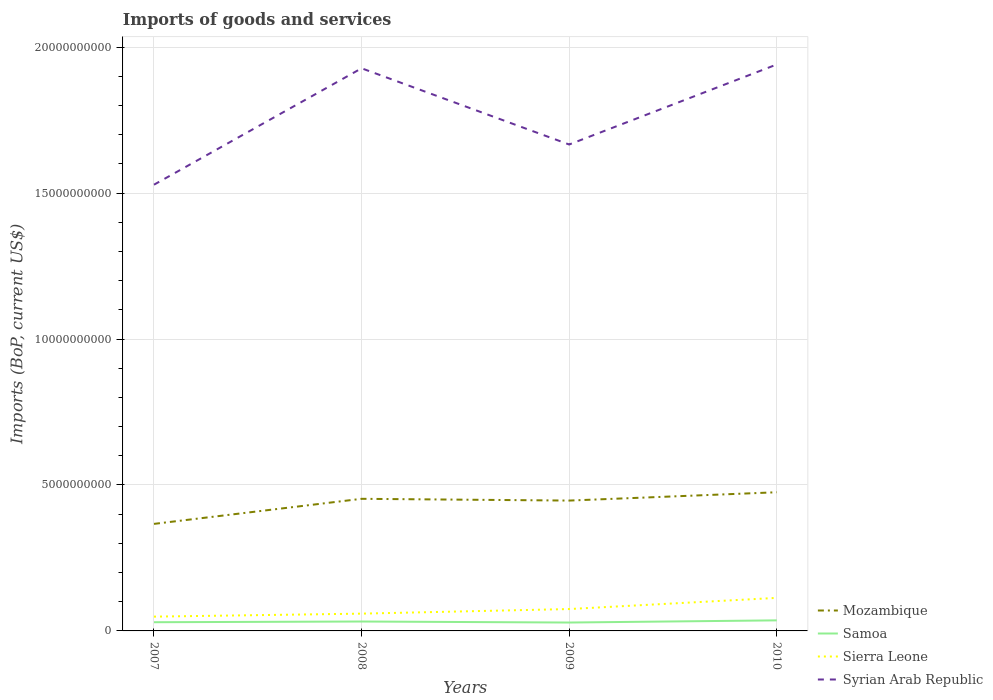Does the line corresponding to Mozambique intersect with the line corresponding to Sierra Leone?
Provide a short and direct response. No. Across all years, what is the maximum amount spent on imports in Sierra Leone?
Make the answer very short. 4.90e+08. In which year was the amount spent on imports in Mozambique maximum?
Offer a terse response. 2007. What is the total amount spent on imports in Syrian Arab Republic in the graph?
Give a very brief answer. -4.12e+09. What is the difference between the highest and the second highest amount spent on imports in Mozambique?
Provide a succinct answer. 1.08e+09. Is the amount spent on imports in Mozambique strictly greater than the amount spent on imports in Syrian Arab Republic over the years?
Your answer should be compact. Yes. How many years are there in the graph?
Offer a terse response. 4. Does the graph contain any zero values?
Ensure brevity in your answer.  No. Does the graph contain grids?
Provide a succinct answer. Yes. What is the title of the graph?
Provide a short and direct response. Imports of goods and services. What is the label or title of the Y-axis?
Offer a very short reply. Imports (BoP, current US$). What is the Imports (BoP, current US$) of Mozambique in 2007?
Offer a very short reply. 3.67e+09. What is the Imports (BoP, current US$) in Samoa in 2007?
Provide a succinct answer. 2.98e+08. What is the Imports (BoP, current US$) of Sierra Leone in 2007?
Make the answer very short. 4.90e+08. What is the Imports (BoP, current US$) in Syrian Arab Republic in 2007?
Your answer should be very brief. 1.53e+1. What is the Imports (BoP, current US$) of Mozambique in 2008?
Provide a succinct answer. 4.53e+09. What is the Imports (BoP, current US$) of Samoa in 2008?
Make the answer very short. 3.22e+08. What is the Imports (BoP, current US$) of Sierra Leone in 2008?
Provide a short and direct response. 5.92e+08. What is the Imports (BoP, current US$) in Syrian Arab Republic in 2008?
Offer a terse response. 1.93e+1. What is the Imports (BoP, current US$) in Mozambique in 2009?
Make the answer very short. 4.47e+09. What is the Imports (BoP, current US$) of Samoa in 2009?
Make the answer very short. 2.87e+08. What is the Imports (BoP, current US$) of Sierra Leone in 2009?
Give a very brief answer. 7.50e+08. What is the Imports (BoP, current US$) in Syrian Arab Republic in 2009?
Provide a succinct answer. 1.67e+1. What is the Imports (BoP, current US$) of Mozambique in 2010?
Your answer should be compact. 4.75e+09. What is the Imports (BoP, current US$) of Samoa in 2010?
Ensure brevity in your answer.  3.62e+08. What is the Imports (BoP, current US$) of Sierra Leone in 2010?
Ensure brevity in your answer.  1.13e+09. What is the Imports (BoP, current US$) in Syrian Arab Republic in 2010?
Offer a terse response. 1.94e+1. Across all years, what is the maximum Imports (BoP, current US$) of Mozambique?
Make the answer very short. 4.75e+09. Across all years, what is the maximum Imports (BoP, current US$) of Samoa?
Offer a terse response. 3.62e+08. Across all years, what is the maximum Imports (BoP, current US$) of Sierra Leone?
Provide a short and direct response. 1.13e+09. Across all years, what is the maximum Imports (BoP, current US$) in Syrian Arab Republic?
Offer a very short reply. 1.94e+1. Across all years, what is the minimum Imports (BoP, current US$) of Mozambique?
Your answer should be compact. 3.67e+09. Across all years, what is the minimum Imports (BoP, current US$) in Samoa?
Make the answer very short. 2.87e+08. Across all years, what is the minimum Imports (BoP, current US$) of Sierra Leone?
Your answer should be compact. 4.90e+08. Across all years, what is the minimum Imports (BoP, current US$) of Syrian Arab Republic?
Your answer should be very brief. 1.53e+1. What is the total Imports (BoP, current US$) of Mozambique in the graph?
Give a very brief answer. 1.74e+1. What is the total Imports (BoP, current US$) in Samoa in the graph?
Provide a short and direct response. 1.27e+09. What is the total Imports (BoP, current US$) of Sierra Leone in the graph?
Your answer should be very brief. 2.96e+09. What is the total Imports (BoP, current US$) of Syrian Arab Republic in the graph?
Give a very brief answer. 7.06e+1. What is the difference between the Imports (BoP, current US$) of Mozambique in 2007 and that in 2008?
Ensure brevity in your answer.  -8.59e+08. What is the difference between the Imports (BoP, current US$) in Samoa in 2007 and that in 2008?
Offer a terse response. -2.43e+07. What is the difference between the Imports (BoP, current US$) of Sierra Leone in 2007 and that in 2008?
Make the answer very short. -1.02e+08. What is the difference between the Imports (BoP, current US$) of Syrian Arab Republic in 2007 and that in 2008?
Offer a very short reply. -3.99e+09. What is the difference between the Imports (BoP, current US$) of Mozambique in 2007 and that in 2009?
Your response must be concise. -7.99e+08. What is the difference between the Imports (BoP, current US$) of Samoa in 2007 and that in 2009?
Provide a short and direct response. 1.07e+07. What is the difference between the Imports (BoP, current US$) of Sierra Leone in 2007 and that in 2009?
Ensure brevity in your answer.  -2.60e+08. What is the difference between the Imports (BoP, current US$) of Syrian Arab Republic in 2007 and that in 2009?
Provide a succinct answer. -1.38e+09. What is the difference between the Imports (BoP, current US$) of Mozambique in 2007 and that in 2010?
Make the answer very short. -1.08e+09. What is the difference between the Imports (BoP, current US$) of Samoa in 2007 and that in 2010?
Provide a succinct answer. -6.36e+07. What is the difference between the Imports (BoP, current US$) in Sierra Leone in 2007 and that in 2010?
Offer a terse response. -6.43e+08. What is the difference between the Imports (BoP, current US$) of Syrian Arab Republic in 2007 and that in 2010?
Your response must be concise. -4.12e+09. What is the difference between the Imports (BoP, current US$) in Mozambique in 2008 and that in 2009?
Ensure brevity in your answer.  6.04e+07. What is the difference between the Imports (BoP, current US$) in Samoa in 2008 and that in 2009?
Ensure brevity in your answer.  3.50e+07. What is the difference between the Imports (BoP, current US$) of Sierra Leone in 2008 and that in 2009?
Provide a short and direct response. -1.57e+08. What is the difference between the Imports (BoP, current US$) of Syrian Arab Republic in 2008 and that in 2009?
Your answer should be compact. 2.61e+09. What is the difference between the Imports (BoP, current US$) in Mozambique in 2008 and that in 2010?
Ensure brevity in your answer.  -2.25e+08. What is the difference between the Imports (BoP, current US$) of Samoa in 2008 and that in 2010?
Your answer should be compact. -3.93e+07. What is the difference between the Imports (BoP, current US$) in Sierra Leone in 2008 and that in 2010?
Give a very brief answer. -5.40e+08. What is the difference between the Imports (BoP, current US$) of Syrian Arab Republic in 2008 and that in 2010?
Provide a succinct answer. -1.30e+08. What is the difference between the Imports (BoP, current US$) in Mozambique in 2009 and that in 2010?
Offer a very short reply. -2.85e+08. What is the difference between the Imports (BoP, current US$) of Samoa in 2009 and that in 2010?
Your answer should be compact. -7.43e+07. What is the difference between the Imports (BoP, current US$) of Sierra Leone in 2009 and that in 2010?
Your answer should be compact. -3.83e+08. What is the difference between the Imports (BoP, current US$) in Syrian Arab Republic in 2009 and that in 2010?
Provide a short and direct response. -2.74e+09. What is the difference between the Imports (BoP, current US$) of Mozambique in 2007 and the Imports (BoP, current US$) of Samoa in 2008?
Your answer should be very brief. 3.35e+09. What is the difference between the Imports (BoP, current US$) in Mozambique in 2007 and the Imports (BoP, current US$) in Sierra Leone in 2008?
Your response must be concise. 3.08e+09. What is the difference between the Imports (BoP, current US$) of Mozambique in 2007 and the Imports (BoP, current US$) of Syrian Arab Republic in 2008?
Offer a terse response. -1.56e+1. What is the difference between the Imports (BoP, current US$) in Samoa in 2007 and the Imports (BoP, current US$) in Sierra Leone in 2008?
Provide a succinct answer. -2.94e+08. What is the difference between the Imports (BoP, current US$) in Samoa in 2007 and the Imports (BoP, current US$) in Syrian Arab Republic in 2008?
Keep it short and to the point. -1.90e+1. What is the difference between the Imports (BoP, current US$) in Sierra Leone in 2007 and the Imports (BoP, current US$) in Syrian Arab Republic in 2008?
Offer a very short reply. -1.88e+1. What is the difference between the Imports (BoP, current US$) of Mozambique in 2007 and the Imports (BoP, current US$) of Samoa in 2009?
Provide a short and direct response. 3.38e+09. What is the difference between the Imports (BoP, current US$) in Mozambique in 2007 and the Imports (BoP, current US$) in Sierra Leone in 2009?
Keep it short and to the point. 2.92e+09. What is the difference between the Imports (BoP, current US$) of Mozambique in 2007 and the Imports (BoP, current US$) of Syrian Arab Republic in 2009?
Provide a short and direct response. -1.30e+1. What is the difference between the Imports (BoP, current US$) of Samoa in 2007 and the Imports (BoP, current US$) of Sierra Leone in 2009?
Your response must be concise. -4.51e+08. What is the difference between the Imports (BoP, current US$) of Samoa in 2007 and the Imports (BoP, current US$) of Syrian Arab Republic in 2009?
Ensure brevity in your answer.  -1.64e+1. What is the difference between the Imports (BoP, current US$) of Sierra Leone in 2007 and the Imports (BoP, current US$) of Syrian Arab Republic in 2009?
Your answer should be very brief. -1.62e+1. What is the difference between the Imports (BoP, current US$) of Mozambique in 2007 and the Imports (BoP, current US$) of Samoa in 2010?
Provide a succinct answer. 3.31e+09. What is the difference between the Imports (BoP, current US$) in Mozambique in 2007 and the Imports (BoP, current US$) in Sierra Leone in 2010?
Provide a short and direct response. 2.54e+09. What is the difference between the Imports (BoP, current US$) of Mozambique in 2007 and the Imports (BoP, current US$) of Syrian Arab Republic in 2010?
Offer a terse response. -1.57e+1. What is the difference between the Imports (BoP, current US$) of Samoa in 2007 and the Imports (BoP, current US$) of Sierra Leone in 2010?
Provide a succinct answer. -8.34e+08. What is the difference between the Imports (BoP, current US$) of Samoa in 2007 and the Imports (BoP, current US$) of Syrian Arab Republic in 2010?
Your answer should be very brief. -1.91e+1. What is the difference between the Imports (BoP, current US$) in Sierra Leone in 2007 and the Imports (BoP, current US$) in Syrian Arab Republic in 2010?
Your answer should be very brief. -1.89e+1. What is the difference between the Imports (BoP, current US$) of Mozambique in 2008 and the Imports (BoP, current US$) of Samoa in 2009?
Make the answer very short. 4.24e+09. What is the difference between the Imports (BoP, current US$) of Mozambique in 2008 and the Imports (BoP, current US$) of Sierra Leone in 2009?
Provide a short and direct response. 3.78e+09. What is the difference between the Imports (BoP, current US$) in Mozambique in 2008 and the Imports (BoP, current US$) in Syrian Arab Republic in 2009?
Your answer should be compact. -1.21e+1. What is the difference between the Imports (BoP, current US$) of Samoa in 2008 and the Imports (BoP, current US$) of Sierra Leone in 2009?
Provide a short and direct response. -4.27e+08. What is the difference between the Imports (BoP, current US$) of Samoa in 2008 and the Imports (BoP, current US$) of Syrian Arab Republic in 2009?
Offer a terse response. -1.63e+1. What is the difference between the Imports (BoP, current US$) of Sierra Leone in 2008 and the Imports (BoP, current US$) of Syrian Arab Republic in 2009?
Your answer should be compact. -1.61e+1. What is the difference between the Imports (BoP, current US$) of Mozambique in 2008 and the Imports (BoP, current US$) of Samoa in 2010?
Provide a short and direct response. 4.17e+09. What is the difference between the Imports (BoP, current US$) of Mozambique in 2008 and the Imports (BoP, current US$) of Sierra Leone in 2010?
Offer a very short reply. 3.39e+09. What is the difference between the Imports (BoP, current US$) of Mozambique in 2008 and the Imports (BoP, current US$) of Syrian Arab Republic in 2010?
Offer a terse response. -1.49e+1. What is the difference between the Imports (BoP, current US$) in Samoa in 2008 and the Imports (BoP, current US$) in Sierra Leone in 2010?
Keep it short and to the point. -8.10e+08. What is the difference between the Imports (BoP, current US$) of Samoa in 2008 and the Imports (BoP, current US$) of Syrian Arab Republic in 2010?
Keep it short and to the point. -1.91e+1. What is the difference between the Imports (BoP, current US$) in Sierra Leone in 2008 and the Imports (BoP, current US$) in Syrian Arab Republic in 2010?
Keep it short and to the point. -1.88e+1. What is the difference between the Imports (BoP, current US$) of Mozambique in 2009 and the Imports (BoP, current US$) of Samoa in 2010?
Provide a succinct answer. 4.10e+09. What is the difference between the Imports (BoP, current US$) in Mozambique in 2009 and the Imports (BoP, current US$) in Sierra Leone in 2010?
Make the answer very short. 3.33e+09. What is the difference between the Imports (BoP, current US$) in Mozambique in 2009 and the Imports (BoP, current US$) in Syrian Arab Republic in 2010?
Provide a short and direct response. -1.49e+1. What is the difference between the Imports (BoP, current US$) of Samoa in 2009 and the Imports (BoP, current US$) of Sierra Leone in 2010?
Your response must be concise. -8.45e+08. What is the difference between the Imports (BoP, current US$) of Samoa in 2009 and the Imports (BoP, current US$) of Syrian Arab Republic in 2010?
Your answer should be compact. -1.91e+1. What is the difference between the Imports (BoP, current US$) of Sierra Leone in 2009 and the Imports (BoP, current US$) of Syrian Arab Republic in 2010?
Provide a succinct answer. -1.87e+1. What is the average Imports (BoP, current US$) in Mozambique per year?
Ensure brevity in your answer.  4.35e+09. What is the average Imports (BoP, current US$) of Samoa per year?
Your response must be concise. 3.17e+08. What is the average Imports (BoP, current US$) in Sierra Leone per year?
Offer a terse response. 7.41e+08. What is the average Imports (BoP, current US$) of Syrian Arab Republic per year?
Provide a succinct answer. 1.77e+1. In the year 2007, what is the difference between the Imports (BoP, current US$) in Mozambique and Imports (BoP, current US$) in Samoa?
Offer a very short reply. 3.37e+09. In the year 2007, what is the difference between the Imports (BoP, current US$) of Mozambique and Imports (BoP, current US$) of Sierra Leone?
Offer a very short reply. 3.18e+09. In the year 2007, what is the difference between the Imports (BoP, current US$) of Mozambique and Imports (BoP, current US$) of Syrian Arab Republic?
Your answer should be very brief. -1.16e+1. In the year 2007, what is the difference between the Imports (BoP, current US$) of Samoa and Imports (BoP, current US$) of Sierra Leone?
Ensure brevity in your answer.  -1.92e+08. In the year 2007, what is the difference between the Imports (BoP, current US$) in Samoa and Imports (BoP, current US$) in Syrian Arab Republic?
Ensure brevity in your answer.  -1.50e+1. In the year 2007, what is the difference between the Imports (BoP, current US$) of Sierra Leone and Imports (BoP, current US$) of Syrian Arab Republic?
Your response must be concise. -1.48e+1. In the year 2008, what is the difference between the Imports (BoP, current US$) of Mozambique and Imports (BoP, current US$) of Samoa?
Your answer should be compact. 4.20e+09. In the year 2008, what is the difference between the Imports (BoP, current US$) in Mozambique and Imports (BoP, current US$) in Sierra Leone?
Keep it short and to the point. 3.93e+09. In the year 2008, what is the difference between the Imports (BoP, current US$) in Mozambique and Imports (BoP, current US$) in Syrian Arab Republic?
Ensure brevity in your answer.  -1.48e+1. In the year 2008, what is the difference between the Imports (BoP, current US$) of Samoa and Imports (BoP, current US$) of Sierra Leone?
Keep it short and to the point. -2.70e+08. In the year 2008, what is the difference between the Imports (BoP, current US$) in Samoa and Imports (BoP, current US$) in Syrian Arab Republic?
Your answer should be compact. -1.90e+1. In the year 2008, what is the difference between the Imports (BoP, current US$) of Sierra Leone and Imports (BoP, current US$) of Syrian Arab Republic?
Provide a short and direct response. -1.87e+1. In the year 2009, what is the difference between the Imports (BoP, current US$) in Mozambique and Imports (BoP, current US$) in Samoa?
Give a very brief answer. 4.18e+09. In the year 2009, what is the difference between the Imports (BoP, current US$) in Mozambique and Imports (BoP, current US$) in Sierra Leone?
Give a very brief answer. 3.72e+09. In the year 2009, what is the difference between the Imports (BoP, current US$) in Mozambique and Imports (BoP, current US$) in Syrian Arab Republic?
Your answer should be compact. -1.22e+1. In the year 2009, what is the difference between the Imports (BoP, current US$) in Samoa and Imports (BoP, current US$) in Sierra Leone?
Keep it short and to the point. -4.62e+08. In the year 2009, what is the difference between the Imports (BoP, current US$) of Samoa and Imports (BoP, current US$) of Syrian Arab Republic?
Your answer should be compact. -1.64e+1. In the year 2009, what is the difference between the Imports (BoP, current US$) in Sierra Leone and Imports (BoP, current US$) in Syrian Arab Republic?
Provide a succinct answer. -1.59e+1. In the year 2010, what is the difference between the Imports (BoP, current US$) of Mozambique and Imports (BoP, current US$) of Samoa?
Provide a short and direct response. 4.39e+09. In the year 2010, what is the difference between the Imports (BoP, current US$) in Mozambique and Imports (BoP, current US$) in Sierra Leone?
Give a very brief answer. 3.62e+09. In the year 2010, what is the difference between the Imports (BoP, current US$) of Mozambique and Imports (BoP, current US$) of Syrian Arab Republic?
Ensure brevity in your answer.  -1.47e+1. In the year 2010, what is the difference between the Imports (BoP, current US$) of Samoa and Imports (BoP, current US$) of Sierra Leone?
Offer a very short reply. -7.71e+08. In the year 2010, what is the difference between the Imports (BoP, current US$) of Samoa and Imports (BoP, current US$) of Syrian Arab Republic?
Provide a short and direct response. -1.90e+1. In the year 2010, what is the difference between the Imports (BoP, current US$) in Sierra Leone and Imports (BoP, current US$) in Syrian Arab Republic?
Your answer should be compact. -1.83e+1. What is the ratio of the Imports (BoP, current US$) of Mozambique in 2007 to that in 2008?
Provide a succinct answer. 0.81. What is the ratio of the Imports (BoP, current US$) of Samoa in 2007 to that in 2008?
Provide a succinct answer. 0.92. What is the ratio of the Imports (BoP, current US$) of Sierra Leone in 2007 to that in 2008?
Give a very brief answer. 0.83. What is the ratio of the Imports (BoP, current US$) in Syrian Arab Republic in 2007 to that in 2008?
Offer a very short reply. 0.79. What is the ratio of the Imports (BoP, current US$) in Mozambique in 2007 to that in 2009?
Ensure brevity in your answer.  0.82. What is the ratio of the Imports (BoP, current US$) in Samoa in 2007 to that in 2009?
Make the answer very short. 1.04. What is the ratio of the Imports (BoP, current US$) of Sierra Leone in 2007 to that in 2009?
Make the answer very short. 0.65. What is the ratio of the Imports (BoP, current US$) of Syrian Arab Republic in 2007 to that in 2009?
Offer a terse response. 0.92. What is the ratio of the Imports (BoP, current US$) in Mozambique in 2007 to that in 2010?
Provide a short and direct response. 0.77. What is the ratio of the Imports (BoP, current US$) in Samoa in 2007 to that in 2010?
Provide a short and direct response. 0.82. What is the ratio of the Imports (BoP, current US$) in Sierra Leone in 2007 to that in 2010?
Offer a very short reply. 0.43. What is the ratio of the Imports (BoP, current US$) of Syrian Arab Republic in 2007 to that in 2010?
Keep it short and to the point. 0.79. What is the ratio of the Imports (BoP, current US$) of Mozambique in 2008 to that in 2009?
Your answer should be very brief. 1.01. What is the ratio of the Imports (BoP, current US$) in Samoa in 2008 to that in 2009?
Your response must be concise. 1.12. What is the ratio of the Imports (BoP, current US$) in Sierra Leone in 2008 to that in 2009?
Your answer should be very brief. 0.79. What is the ratio of the Imports (BoP, current US$) of Syrian Arab Republic in 2008 to that in 2009?
Make the answer very short. 1.16. What is the ratio of the Imports (BoP, current US$) of Mozambique in 2008 to that in 2010?
Give a very brief answer. 0.95. What is the ratio of the Imports (BoP, current US$) in Samoa in 2008 to that in 2010?
Your answer should be compact. 0.89. What is the ratio of the Imports (BoP, current US$) in Sierra Leone in 2008 to that in 2010?
Make the answer very short. 0.52. What is the ratio of the Imports (BoP, current US$) in Samoa in 2009 to that in 2010?
Your answer should be compact. 0.79. What is the ratio of the Imports (BoP, current US$) of Sierra Leone in 2009 to that in 2010?
Provide a short and direct response. 0.66. What is the ratio of the Imports (BoP, current US$) in Syrian Arab Republic in 2009 to that in 2010?
Provide a short and direct response. 0.86. What is the difference between the highest and the second highest Imports (BoP, current US$) of Mozambique?
Provide a succinct answer. 2.25e+08. What is the difference between the highest and the second highest Imports (BoP, current US$) in Samoa?
Offer a very short reply. 3.93e+07. What is the difference between the highest and the second highest Imports (BoP, current US$) in Sierra Leone?
Provide a short and direct response. 3.83e+08. What is the difference between the highest and the second highest Imports (BoP, current US$) in Syrian Arab Republic?
Provide a short and direct response. 1.30e+08. What is the difference between the highest and the lowest Imports (BoP, current US$) in Mozambique?
Offer a terse response. 1.08e+09. What is the difference between the highest and the lowest Imports (BoP, current US$) of Samoa?
Offer a terse response. 7.43e+07. What is the difference between the highest and the lowest Imports (BoP, current US$) of Sierra Leone?
Provide a succinct answer. 6.43e+08. What is the difference between the highest and the lowest Imports (BoP, current US$) in Syrian Arab Republic?
Ensure brevity in your answer.  4.12e+09. 